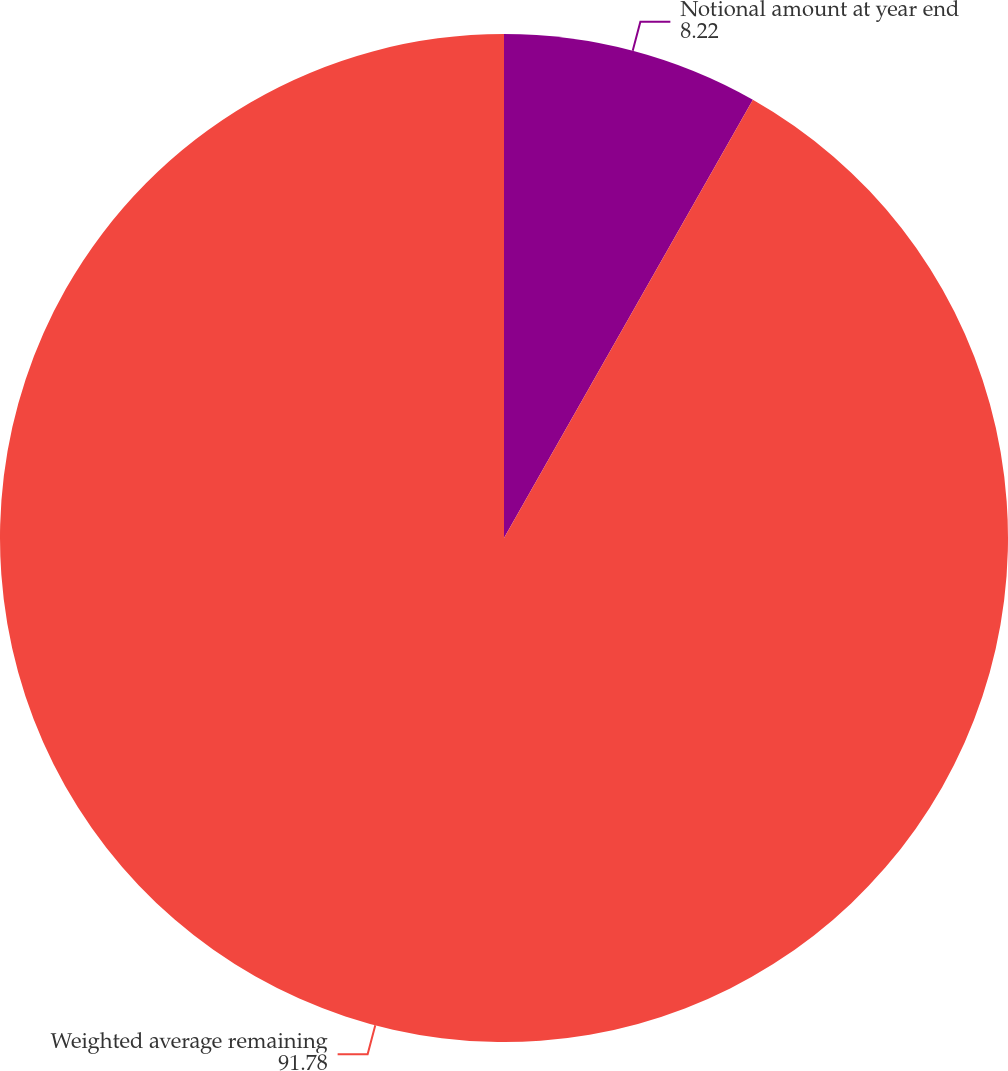Convert chart to OTSL. <chart><loc_0><loc_0><loc_500><loc_500><pie_chart><fcel>Notional amount at year end<fcel>Weighted average remaining<nl><fcel>8.22%<fcel>91.78%<nl></chart> 